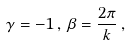Convert formula to latex. <formula><loc_0><loc_0><loc_500><loc_500>\gamma = - 1 \, , \, \beta = \frac { 2 \pi } k \, ,</formula> 